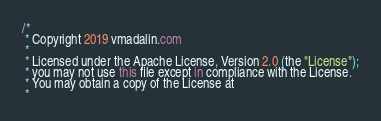Convert code to text. <code><loc_0><loc_0><loc_500><loc_500><_Kotlin_>/*
 * Copyright 2019 vmadalin.com
 *
 * Licensed under the Apache License, Version 2.0 (the "License");
 * you may not use this file except in compliance with the License.
 * You may obtain a copy of the License at
 *</code> 